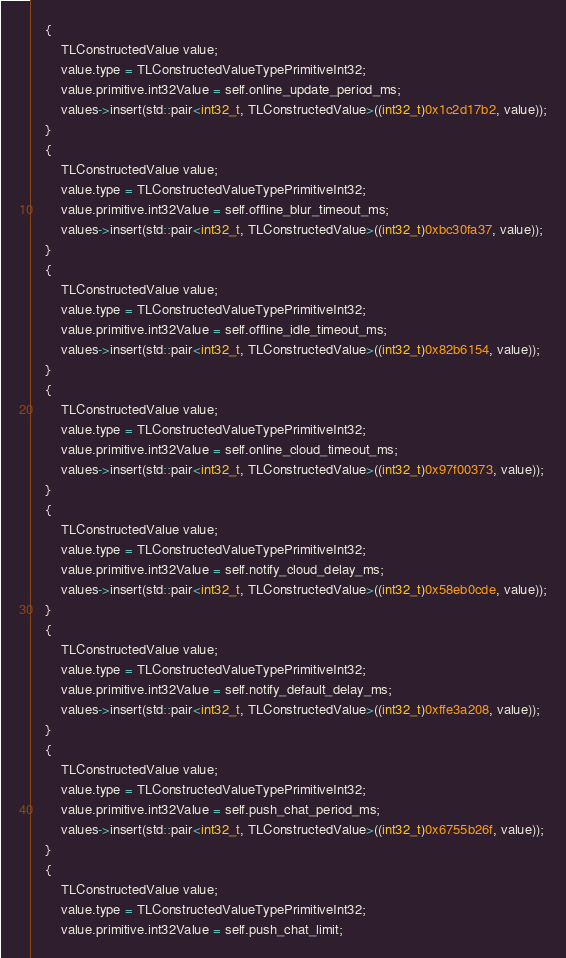Convert code to text. <code><loc_0><loc_0><loc_500><loc_500><_ObjectiveC_>    {
        TLConstructedValue value;
        value.type = TLConstructedValueTypePrimitiveInt32;
        value.primitive.int32Value = self.online_update_period_ms;
        values->insert(std::pair<int32_t, TLConstructedValue>((int32_t)0x1c2d17b2, value));
    }
    {
        TLConstructedValue value;
        value.type = TLConstructedValueTypePrimitiveInt32;
        value.primitive.int32Value = self.offline_blur_timeout_ms;
        values->insert(std::pair<int32_t, TLConstructedValue>((int32_t)0xbc30fa37, value));
    }
    {
        TLConstructedValue value;
        value.type = TLConstructedValueTypePrimitiveInt32;
        value.primitive.int32Value = self.offline_idle_timeout_ms;
        values->insert(std::pair<int32_t, TLConstructedValue>((int32_t)0x82b6154, value));
    }
    {
        TLConstructedValue value;
        value.type = TLConstructedValueTypePrimitiveInt32;
        value.primitive.int32Value = self.online_cloud_timeout_ms;
        values->insert(std::pair<int32_t, TLConstructedValue>((int32_t)0x97f00373, value));
    }
    {
        TLConstructedValue value;
        value.type = TLConstructedValueTypePrimitiveInt32;
        value.primitive.int32Value = self.notify_cloud_delay_ms;
        values->insert(std::pair<int32_t, TLConstructedValue>((int32_t)0x58eb0cde, value));
    }
    {
        TLConstructedValue value;
        value.type = TLConstructedValueTypePrimitiveInt32;
        value.primitive.int32Value = self.notify_default_delay_ms;
        values->insert(std::pair<int32_t, TLConstructedValue>((int32_t)0xffe3a208, value));
    }
    {
        TLConstructedValue value;
        value.type = TLConstructedValueTypePrimitiveInt32;
        value.primitive.int32Value = self.push_chat_period_ms;
        values->insert(std::pair<int32_t, TLConstructedValue>((int32_t)0x6755b26f, value));
    }
    {
        TLConstructedValue value;
        value.type = TLConstructedValueTypePrimitiveInt32;
        value.primitive.int32Value = self.push_chat_limit;</code> 